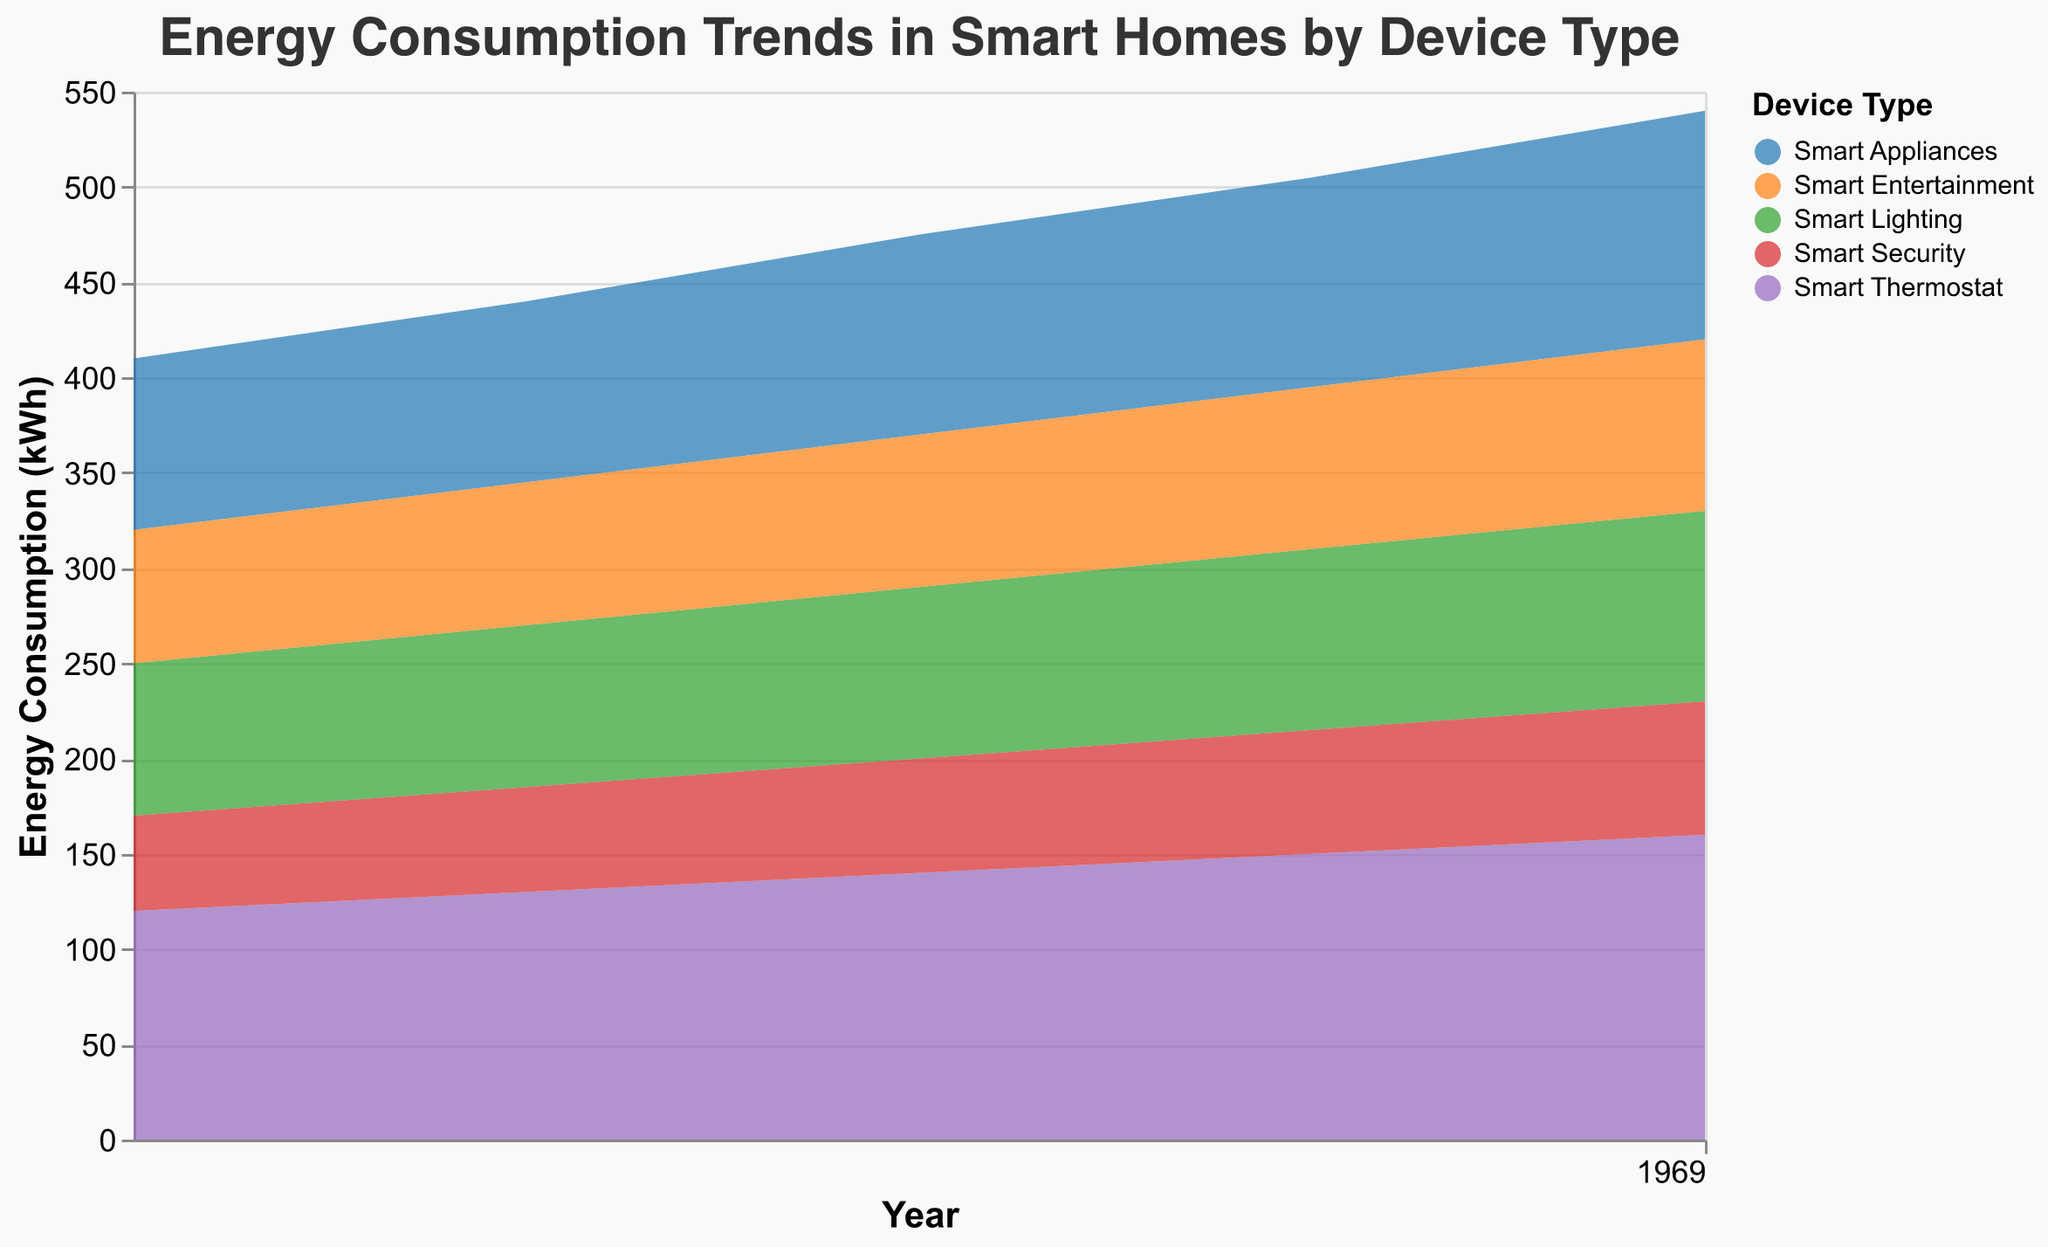What is the title of the figure? The title is generally displayed at the top of the chart and provides a summary of the chart contents. In this case, it outlines the theme of the chart.
Answer: Energy Consumption Trends in Smart Homes by Device Type Which device type consumed the most energy in 2022? To find this, look at the data for the year 2022 and identify the device type with the highest energy consumption value.
Answer: Smart Thermostat How does energy consumption of Smart Lighting change from 2018 to 2022? To determine this, observe the data points for Smart Lighting from 2018 to 2022 and note the energy consumption values for each year.
Answer: It increases from 80 kWh in 2018 to 100 kWh in 2022 What is the total energy consumption for Smart Appliances in 2020 and 2021 combined? Add the energy consumption for Smart Appliances in the years 2020 and 2021.
Answer: 215 kWh Compare the energy consumption trends of Smart Thermostat and Smart Security from 2018 to 2022. Look at the data points for both device types over the years and compare their changing values. Smart Thermostat shows a steady increase each year, while Smart Security shows a smaller, steady increase.
Answer: Smart Thermostat increases more significantly than Smart Security Which year saw the highest total energy consumption for Smart Entertainment? Sum the energy consumption of Smart Entertainment for each year and identify the highest value.
Answer: 2022 What is the average yearly energy consumption for Smart Thermostat between 2018 and 2022? Add up the annual energy consumption of Smart Thermostat from 2018 to 2022 and divide by the number of years covered (5).
Answer: 140 kWh Which device type had the smallest increase in energy consumption from 2018 to 2022? Calculate the difference in energy consumption between 2018 and 2022 for all device types and identify the smallest increase.
Answer: Smart Security What is the total energy consumption for all device types in 2020? Add the energy consumption values for all device types in 2020.
Answer: 475 kWh What trend can be seen in the overall energy consumption across all device types from 2018 to 2022? Observe the changes in combined energy consumption values each year to identify a general pattern or trend.
Answer: Increasing trend 